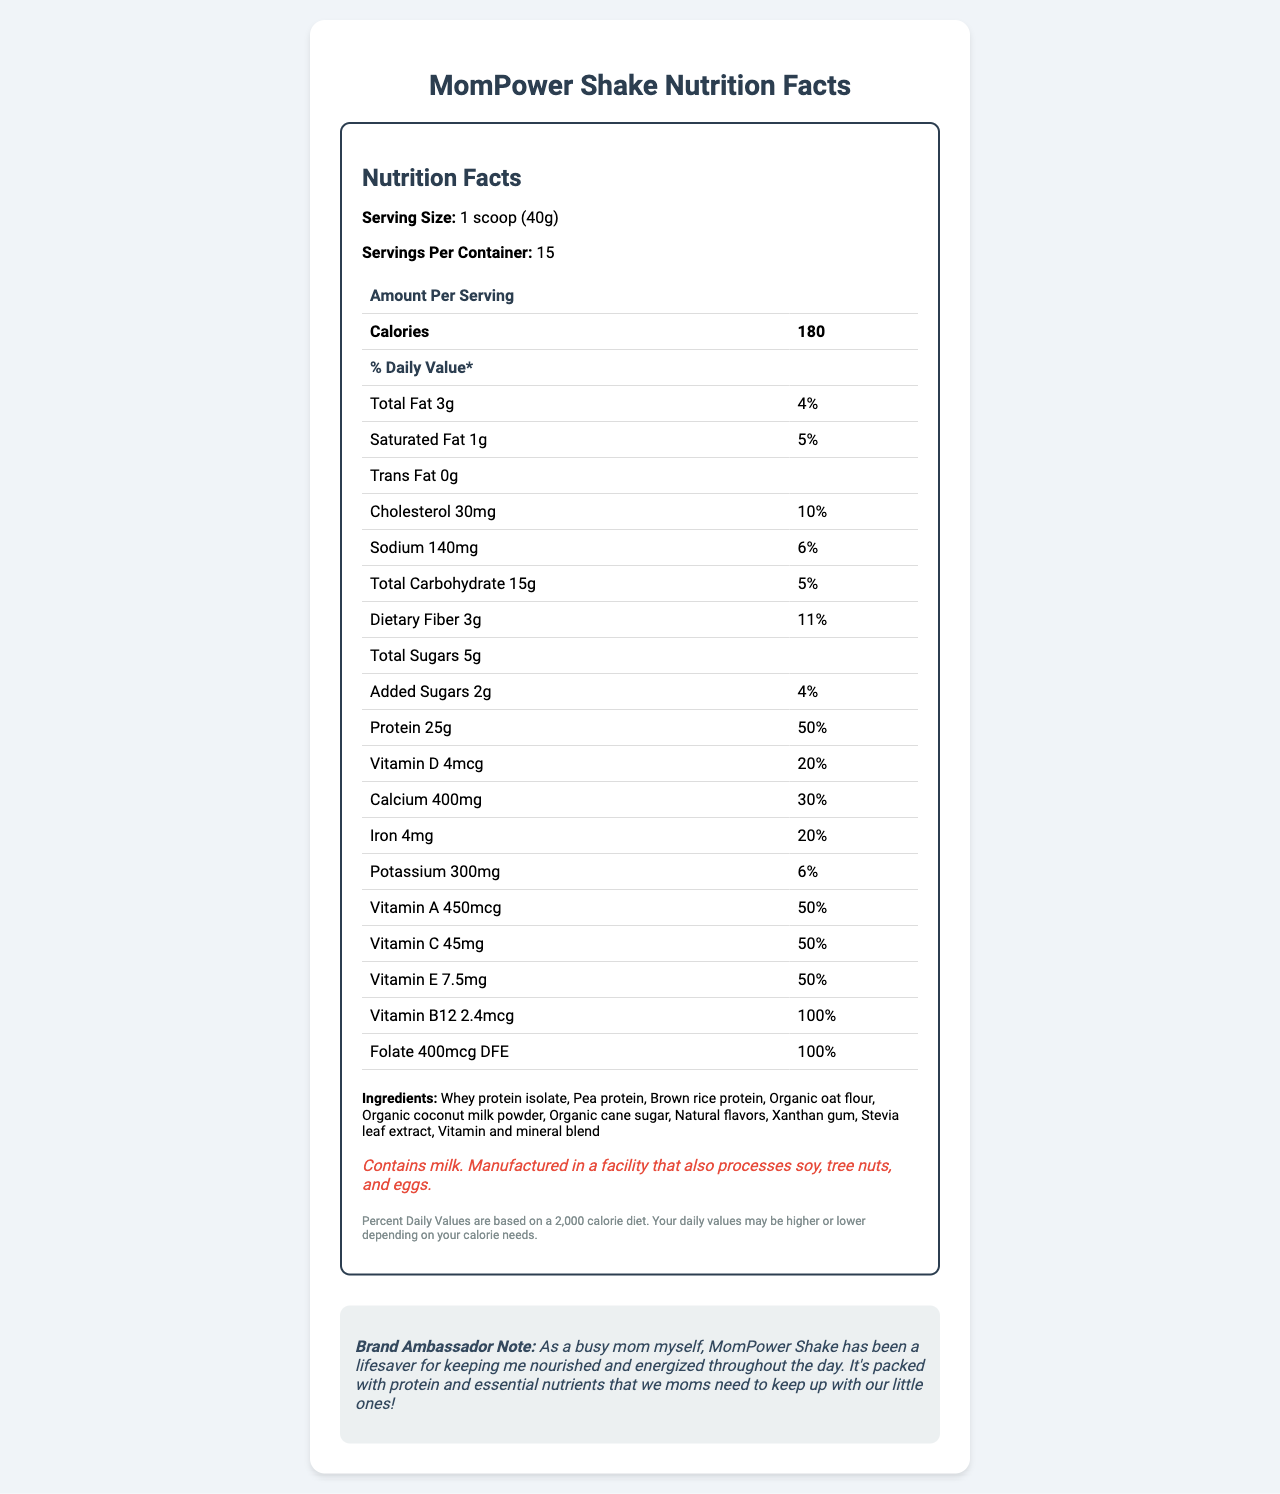what is the serving size for MomPower Shake? The serving size is clearly stated at the beginning of the Nutrition Facts section.
Answer: 1 scoop (40g) how many servings are there in one container of MomPower Shake? The document specifies that there are 15 servings per container.
Answer: 15 how much protein does one serving of MomPower Shake contain? The document states that one serving of the MomPower Shake contains 25g of protein.
Answer: 25g what is the percentage daily value of Vitamin B12 per serving? The document lists the daily value percentage of Vitamin B12 as 100%.
Answer: 100% how many calories are in one serving of MomPower Shake? The document specifies that one serving contains 180 calories.
Answer: 180 what is the total fat per serving for MomPower Shake? A. 1g B. 3g C. 5g D. 4g The document mentions that the total fat per serving is 3g.
Answer: B which of the following is NOT an ingredient in MomPower Shake? I. Organic cane sugar II. Pea protein III. Corn syrup The document lists organic cane sugar and pea protein, but does not list corn syrup among the ingredients.
Answer: III does the MomPower Shake contain milk? The allergen information in the document indicates that the shake contains milk.
Answer: Yes does this product contain any trans fat? The document explicitly states that there is 0g of trans fat in the shake.
Answer: No summarize the main idea of the MomPower Shake Nutrition Facts label. The document provides detailed nutritional information, ingredient list, allergen info, and a note from a brand ambassador, emphasizing the product's suitability for busy moms.
Answer: The MomPower Shake is a protein-rich meal replacement designed for busy moms. One serving (40g) provides 180 calories, 25g of protein, and various vitamins and minerals. The shake includes ingredients like whey protein isolate, pea protein, and organic oat flour. It also contains milk and is manufactured in a facility that processes soy, tree nuts, and eggs. how many grams of dietary fiber are there per serving? The document states that one serving contains 3g of dietary fiber.
Answer: 3g what are the potential allergens mentioned in the document? The allergen information notes that the product contains milk and is manufactured in a facility that also processes soy, tree nuts, and eggs.
Answer: Milk, soy, tree nuts, eggs what is the daily value percentage of calcium per serving? A. 10% B. 20% C. 30% D. 40% The document indicates that the daily value percentage for calcium is 30%.
Answer: C how many grams of added sugars are in one serving of MomPower Shake? The document specifies that there are 2g of added sugars per serving.
Answer: 2g can you determine the manufacturing process of MomPower Shake from the document? The document does not provide any information regarding the manufacturing process of the shake.
Answer: Cannot be determined 